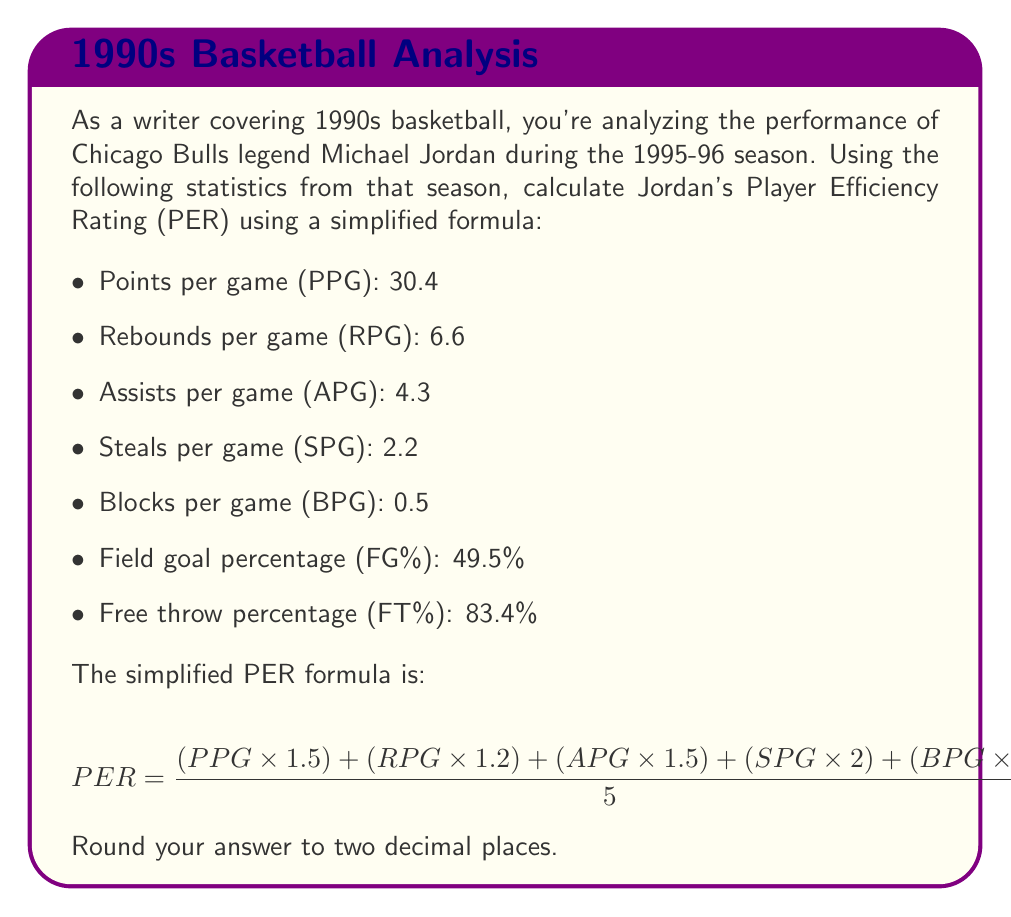Provide a solution to this math problem. To calculate Michael Jordan's Player Efficiency Rating (PER) for the 1995-96 season, we'll follow these steps:

1. First, let's calculate the numerator of the fraction inside the PER formula:
   $$ (30.4 \times 1.5) + (6.6 \times 1.2) + (4.3 \times 1.5) + (2.2 \times 2) + (0.5 \times 2) $$
   $$ = 45.6 + 7.92 + 6.45 + 4.4 + 1 $$
   $$ = 65.37 $$

2. Now, divide this result by 5:
   $$ \frac{65.37}{5} = 13.074 $$

3. Next, we need to multiply this by the sum of FG% and FT%:
   FG% = 49.5% = 0.495
   FT% = 83.4% = 0.834
   $$ 13.074 \times (0.495 + 0.834) = 13.074 \times 1.329 = 17.37 $$

4. Rounding to two decimal places:
   $$ PER = 17.37 $$
Answer: 17.37 